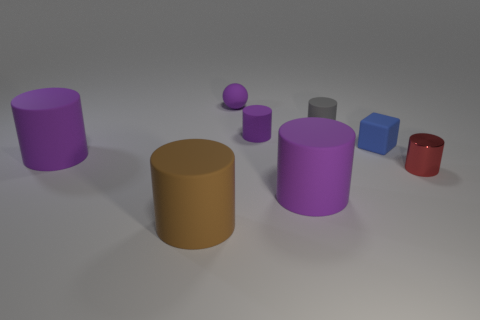Subtract all brown cylinders. How many cylinders are left? 5 Subtract all green blocks. How many purple cylinders are left? 3 Subtract all red cylinders. How many cylinders are left? 5 Subtract 2 cylinders. How many cylinders are left? 4 Add 2 small red metallic objects. How many objects exist? 10 Subtract all cylinders. How many objects are left? 2 Subtract all green cylinders. Subtract all blue blocks. How many cylinders are left? 6 Subtract all big things. Subtract all small gray cylinders. How many objects are left? 4 Add 3 small purple objects. How many small purple objects are left? 5 Add 3 gray cylinders. How many gray cylinders exist? 4 